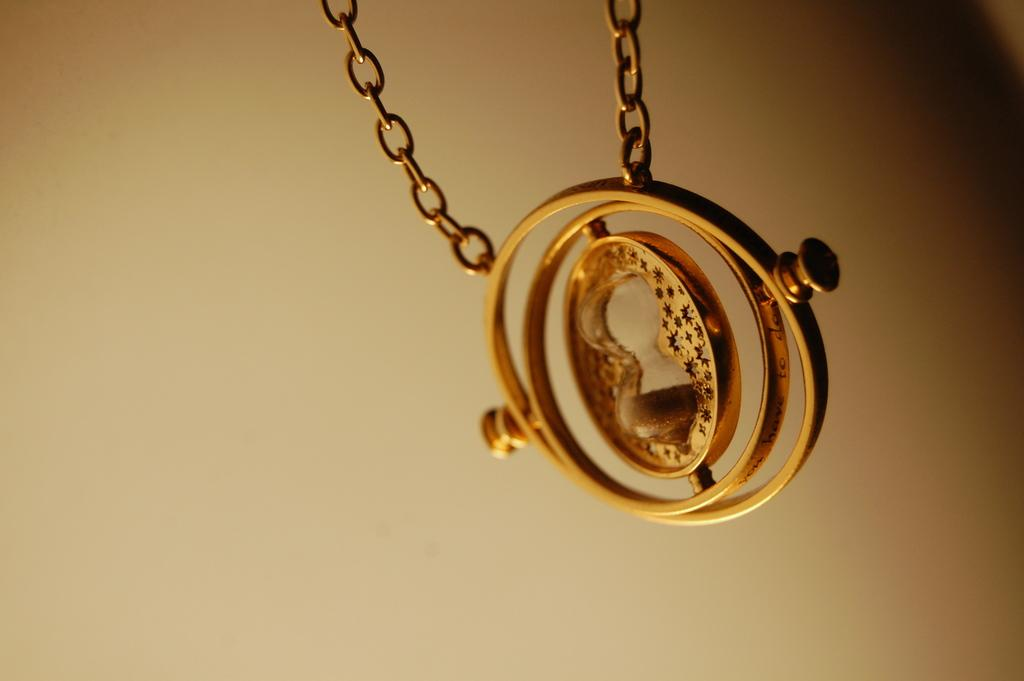What type of object can be seen in the image? There is a metal chain with a circle-shaped locket attached to it in the image. Can you describe the locket in more detail? The locket is attached to the chain and has a circular shape. What can be observed about the background of the image? The background of the image is blurry. How does the locket help the person build muscle in the image? The image does not show any person or activity related to building muscle, and the locket is not associated with such an activity. 